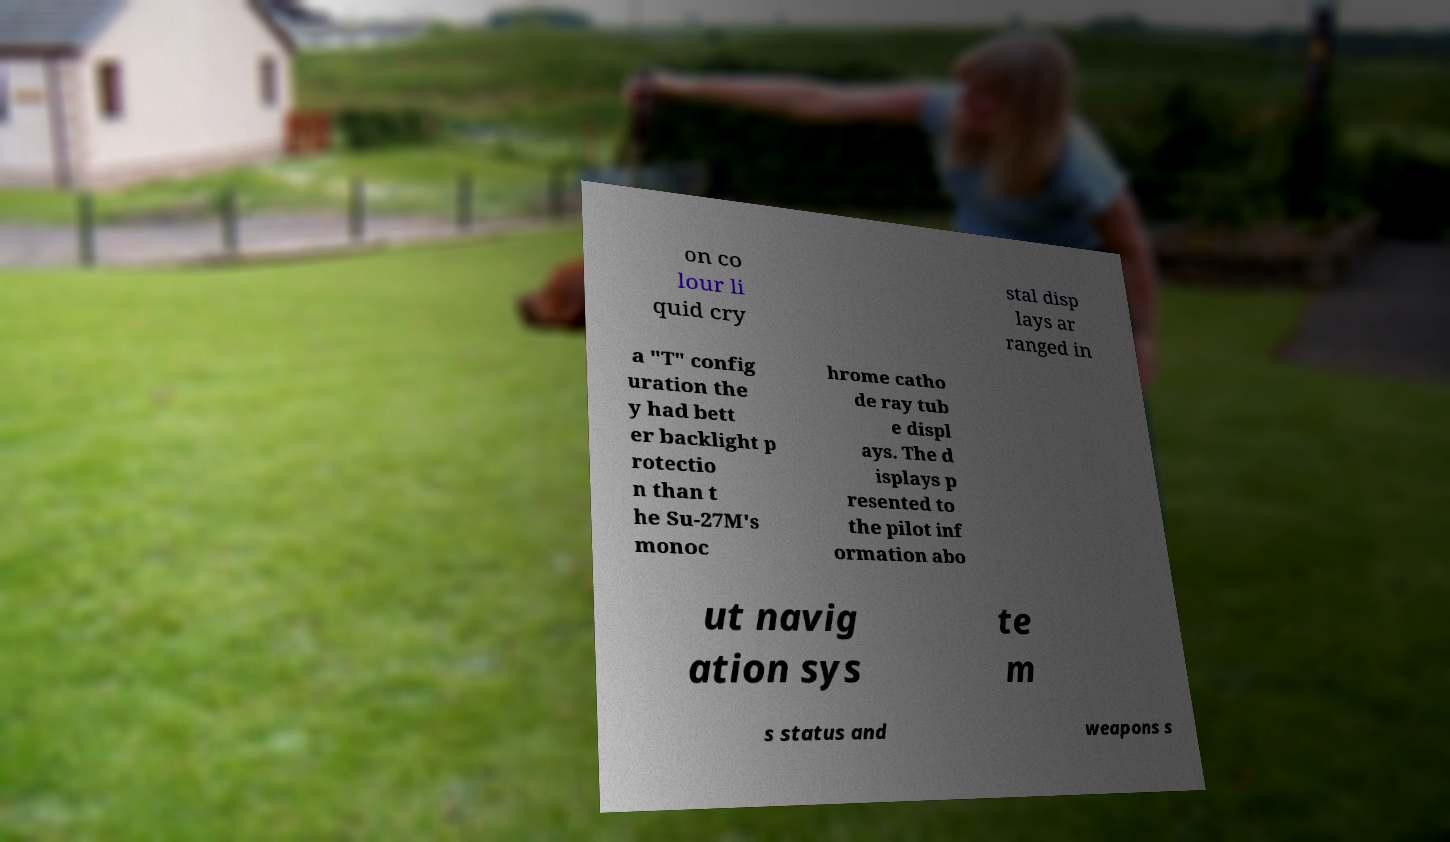There's text embedded in this image that I need extracted. Can you transcribe it verbatim? on co lour li quid cry stal disp lays ar ranged in a "T" config uration the y had bett er backlight p rotectio n than t he Su-27M's monoc hrome catho de ray tub e displ ays. The d isplays p resented to the pilot inf ormation abo ut navig ation sys te m s status and weapons s 